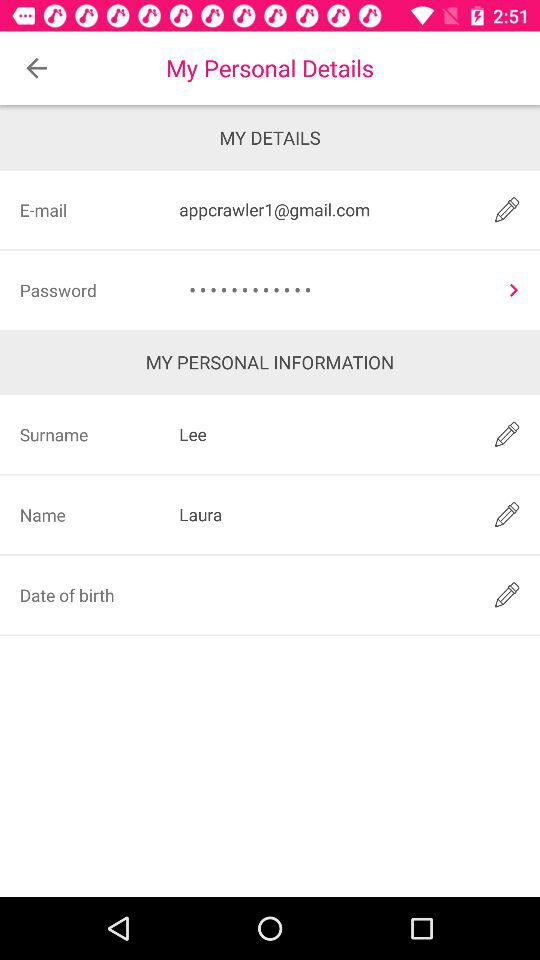What is the email address? The email address is appcrawler1@gmail.com. 